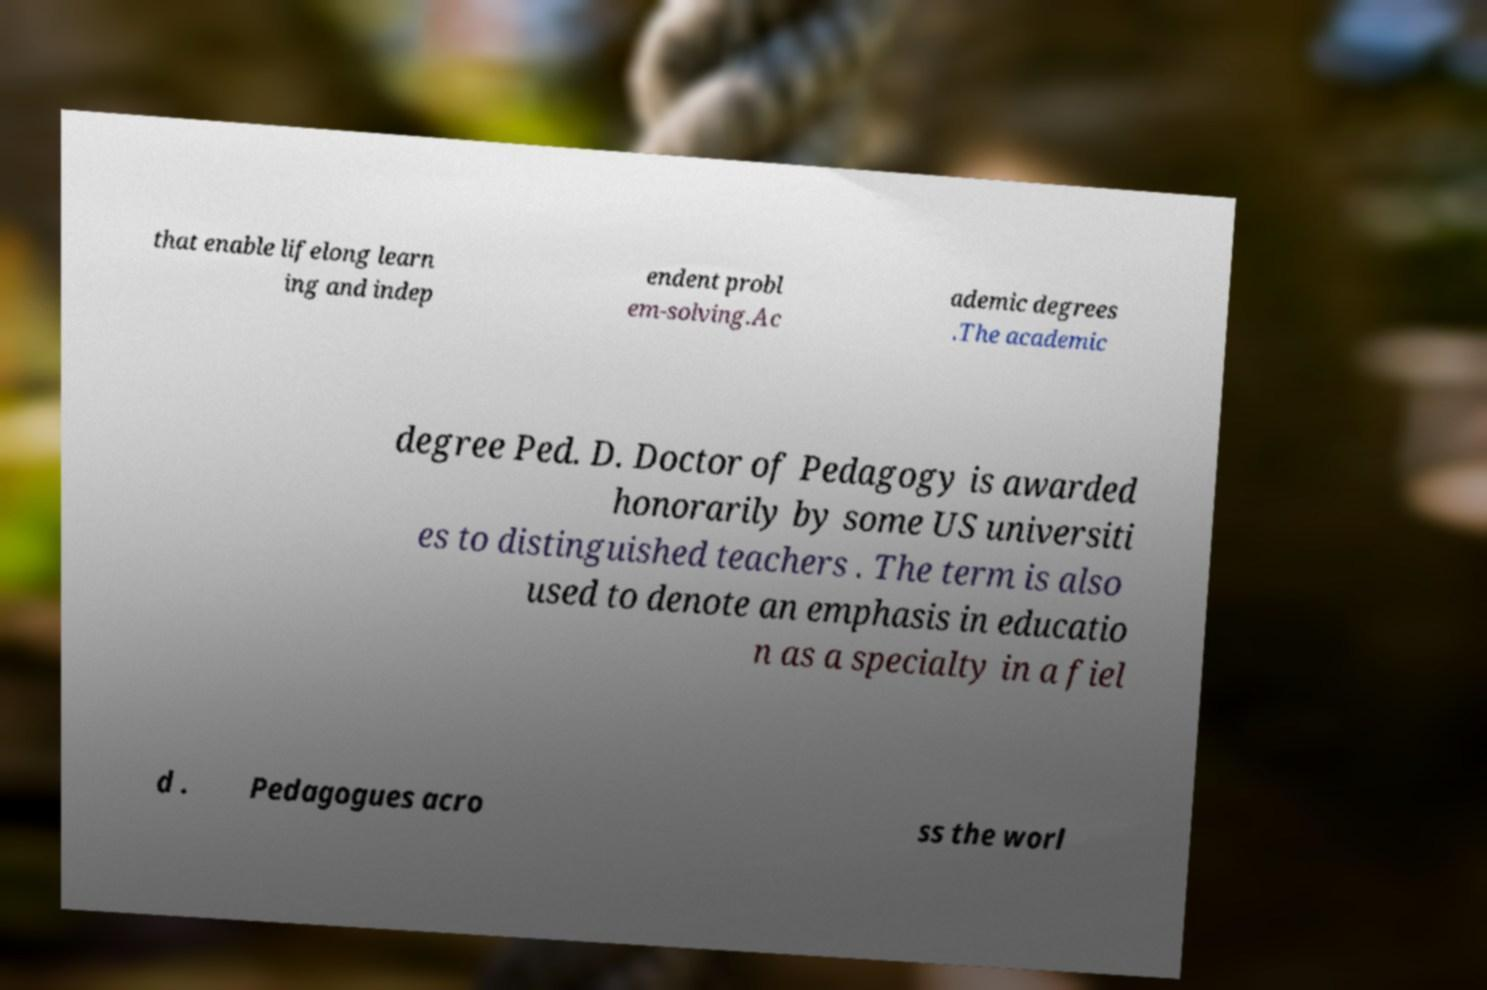Please read and relay the text visible in this image. What does it say? that enable lifelong learn ing and indep endent probl em-solving.Ac ademic degrees .The academic degree Ped. D. Doctor of Pedagogy is awarded honorarily by some US universiti es to distinguished teachers . The term is also used to denote an emphasis in educatio n as a specialty in a fiel d . Pedagogues acro ss the worl 